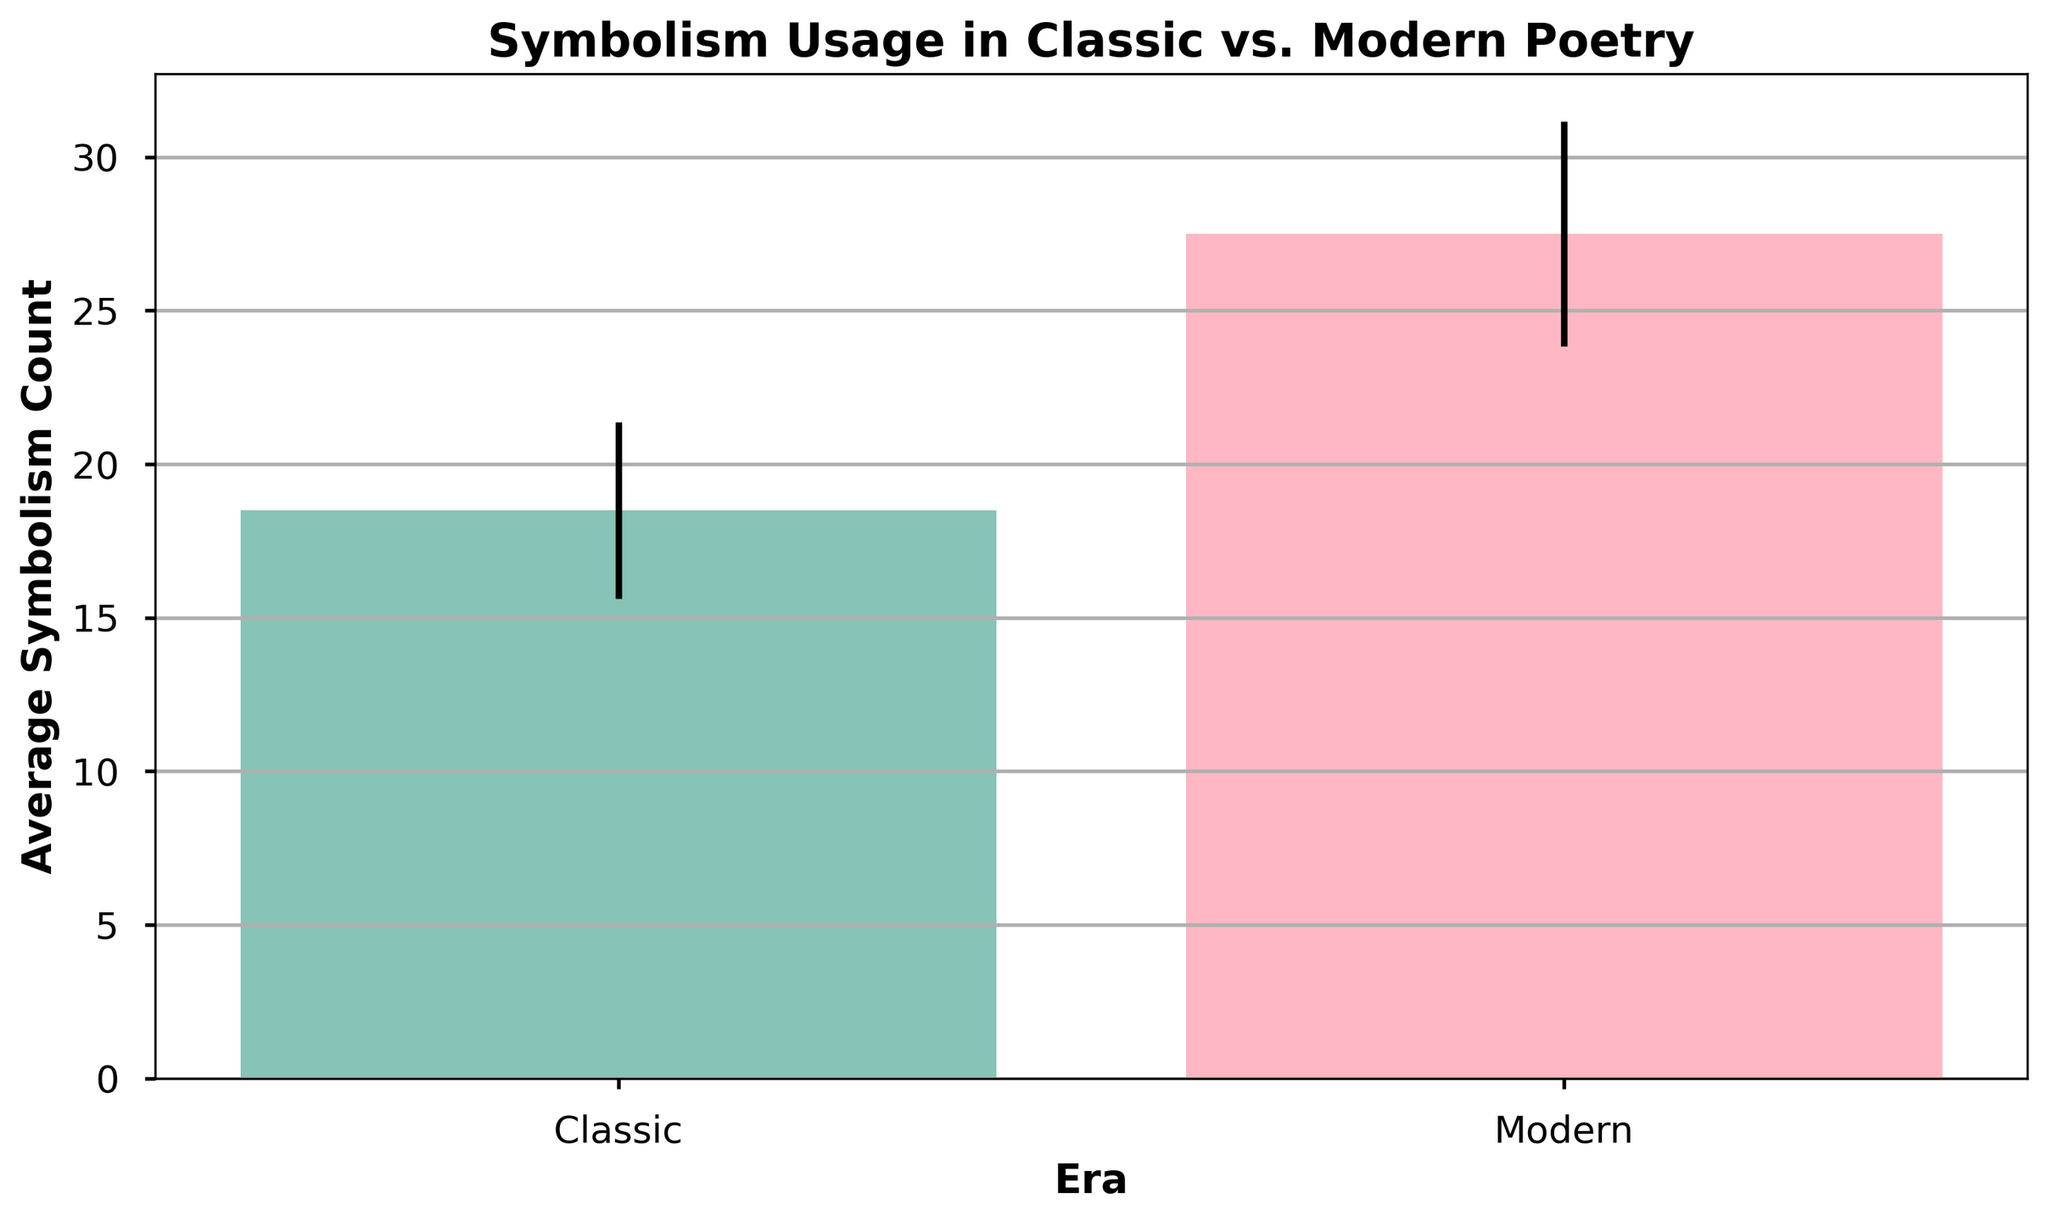What is the average symbolism count in Classic poetry? To find the average symbolism count, sum up the means of the symbolism counts for the Classic era and divide by the total number of observations. Classic: Mean = (15 + 20 + 18 + 22 + 17 + 19 + 21 + 16) / 8 = 18.5
Answer: 18.5 What is the average symbolism count in Modern poetry? To find the average symbolism count for the Modern era, add up the symbolism counts and divide by the total number of observations. Modern: Mean = (25 + 27 + 30 + 28 + 26 + 29 + 31 + 24) / 8 = 27.5
Answer: 27.5 Which era has a higher average symbolism count? Compare the average symbolism counts of both eras: Classic (18.5) and Modern (27.5). Since 27.5 > 18.5, Modern poetry has a higher average symbolism count.
Answer: Modern What is the difference in the average symbolism count between Classic and Modern poetry? Subtract the average symbolism count of Classic poetry from that of Modern poetry: 27.5 - 18.5 = 9
Answer: 9 Which era has a higher standard deviation in symbolism usage and what does it indicate? Compare the average standard deviations of both eras: Classic (approx. 2.85) and Modern (approx. 3.65). Since 3.65 > 2.85, Modern poetry has a higher standard deviation, indicating a greater variability in symbolism usage.
Answer: Modern How much higher is the average symbolism count in Modern poetry compared to Classic poetry? Subtract the average symbolism count of Classic poetry from that of Modern poetry: 27.5 - 18.5 = 9. Modern poetry's symbolism count is higher by 9 units.
Answer: 9 units Which bar represents the Classic era and how can you tell? Identify the color and position of the bars. The Classic era bar is either green (pointed first) because it corresponds to the leftmost bar. The position and corresponding labeling on the x-axis indicate this.
Answer: Left bar, green What does the error bar represent in this chart? The error bars represent the standard deviations of the symbolism counts for each era. The length indicates the variability or dispersion of the data around the mean for each group.
Answer: Standard deviation If one were to sum up the average symbolism counts for both eras, what would the total be? Add the average symbolism counts of both eras: 18.5 (Classic) + 27.5 (Modern) = 46
Answer: 46 Looking at the bars, which visual attribute suggests a more consistent use of symbolism? The length of the error bars can indicate consistency. Shorter error bars suggest less variability, thus more consistent use of symbolism. Classic poetry has shorter error bars on average, indicating more consistency.
Answer: Shorter error bars of the Classic era 